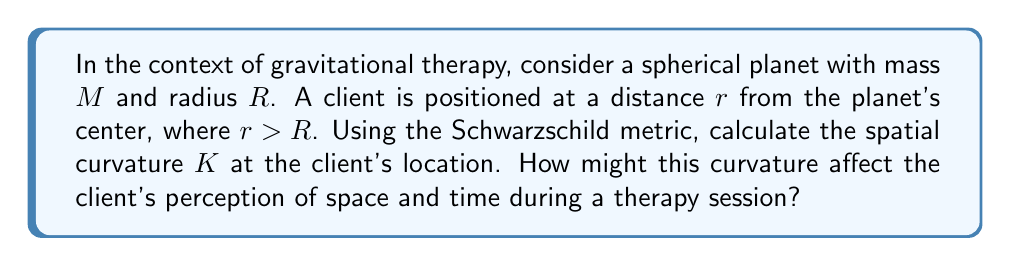Provide a solution to this math problem. Let's approach this step-by-step:

1) The Schwarzschild metric in spherical coordinates is given by:

   $$ds^2 = -\left(1-\frac{2GM}{c^2r}\right)c^2dt^2 + \left(1-\frac{2GM}{c^2r}\right)^{-1}dr^2 + r^2(d\theta^2 + \sin^2\theta d\phi^2)$$

2) The spatial part of this metric (considering only the radial direction) is:

   $$g_{rr} = \left(1-\frac{2GM}{c^2r}\right)^{-1}$$

3) The spatial curvature $K$ is related to the Ricci scalar $R$ of the 3-dimensional spatial hypersurface. For the Schwarzschild metric, this is given by:

   $$K = \frac{R}{6} = \frac{2GM}{c^2r^3}$$

4) Substituting the given values:

   $$K = \frac{2GM}{c^2r^3}$$

5) This equation shows that the spatial curvature decreases with the cube of the distance from the center of the gravitational source.

6) From a therapeutic perspective, this curvature could affect the client's perception of space and time. As the curvature increases (closer to the planet), time would appear to slow down for an outside observer, and spatial distances would appear to stretch. This could potentially impact the client's sense of duration during the therapy session and their perception of physical space.
Answer: $K = \frac{2GM}{c^2r^3}$ 